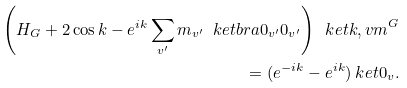Convert formula to latex. <formula><loc_0><loc_0><loc_500><loc_500>\left ( H _ { G } + 2 \cos k - e ^ { i k } \sum _ { v ^ { \prime } } m _ { v ^ { \prime } } \ k e t b r a { 0 _ { v ^ { \prime } } } { 0 _ { v ^ { \prime } } } \right ) \ k e t { k , v m } ^ { G } \\ = ( e ^ { - i k } - e ^ { i k } ) \ k e t { 0 _ { v } } .</formula> 